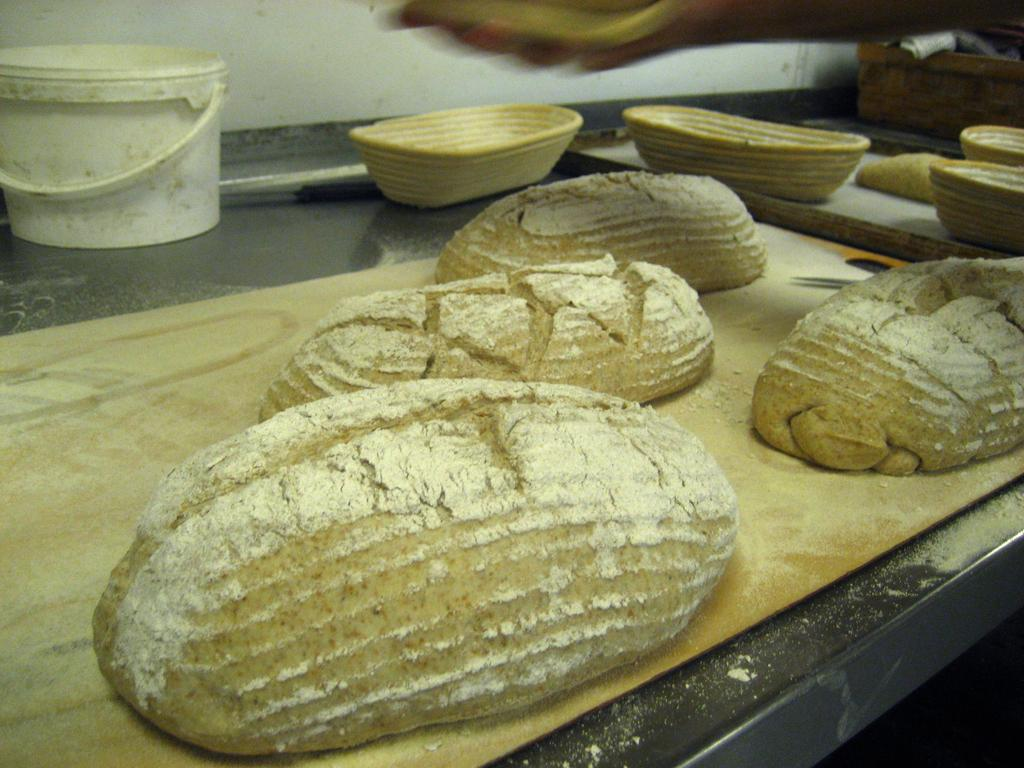What is the main subject in the center of the image? There is food in the center of the image. What type of containers are present in the image? There are baskets and a white bucket in the image. Can you describe the object on the right side of the image? Unfortunately, the facts provided do not specify the object on the right side of the image. What type of wax is being used to cause a reaction with the food in the image? There is no mention of wax or any reaction involving wax in the image. 